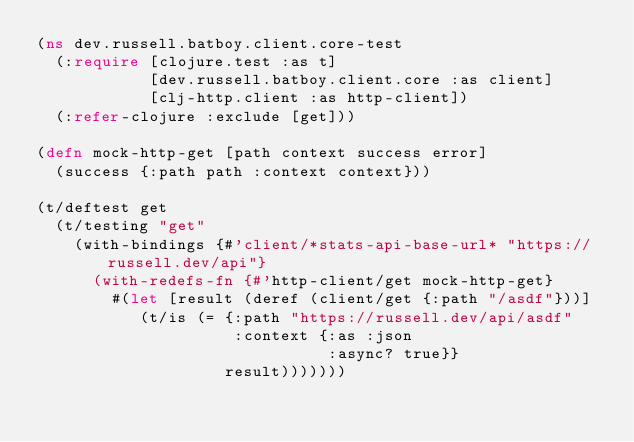<code> <loc_0><loc_0><loc_500><loc_500><_Clojure_>(ns dev.russell.batboy.client.core-test
  (:require [clojure.test :as t]
            [dev.russell.batboy.client.core :as client]
            [clj-http.client :as http-client])
  (:refer-clojure :exclude [get]))

(defn mock-http-get [path context success error]
  (success {:path path :context context}))

(t/deftest get
  (t/testing "get"
    (with-bindings {#'client/*stats-api-base-url* "https://russell.dev/api"}
      (with-redefs-fn {#'http-client/get mock-http-get}
        #(let [result (deref (client/get {:path "/asdf"}))]
           (t/is (= {:path "https://russell.dev/api/asdf"
                     :context {:as :json
                               :async? true}}
                    result)))))))
</code> 